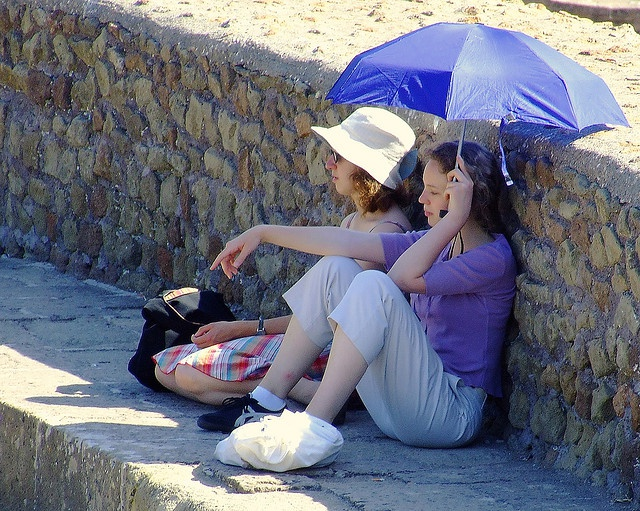Describe the objects in this image and their specific colors. I can see people in gray, darkgray, and navy tones, umbrella in gray, lightblue, lavender, darkblue, and blue tones, people in gray, ivory, and darkgray tones, handbag in gray, ivory, darkgray, and lightblue tones, and handbag in gray, black, navy, and darkgray tones in this image. 